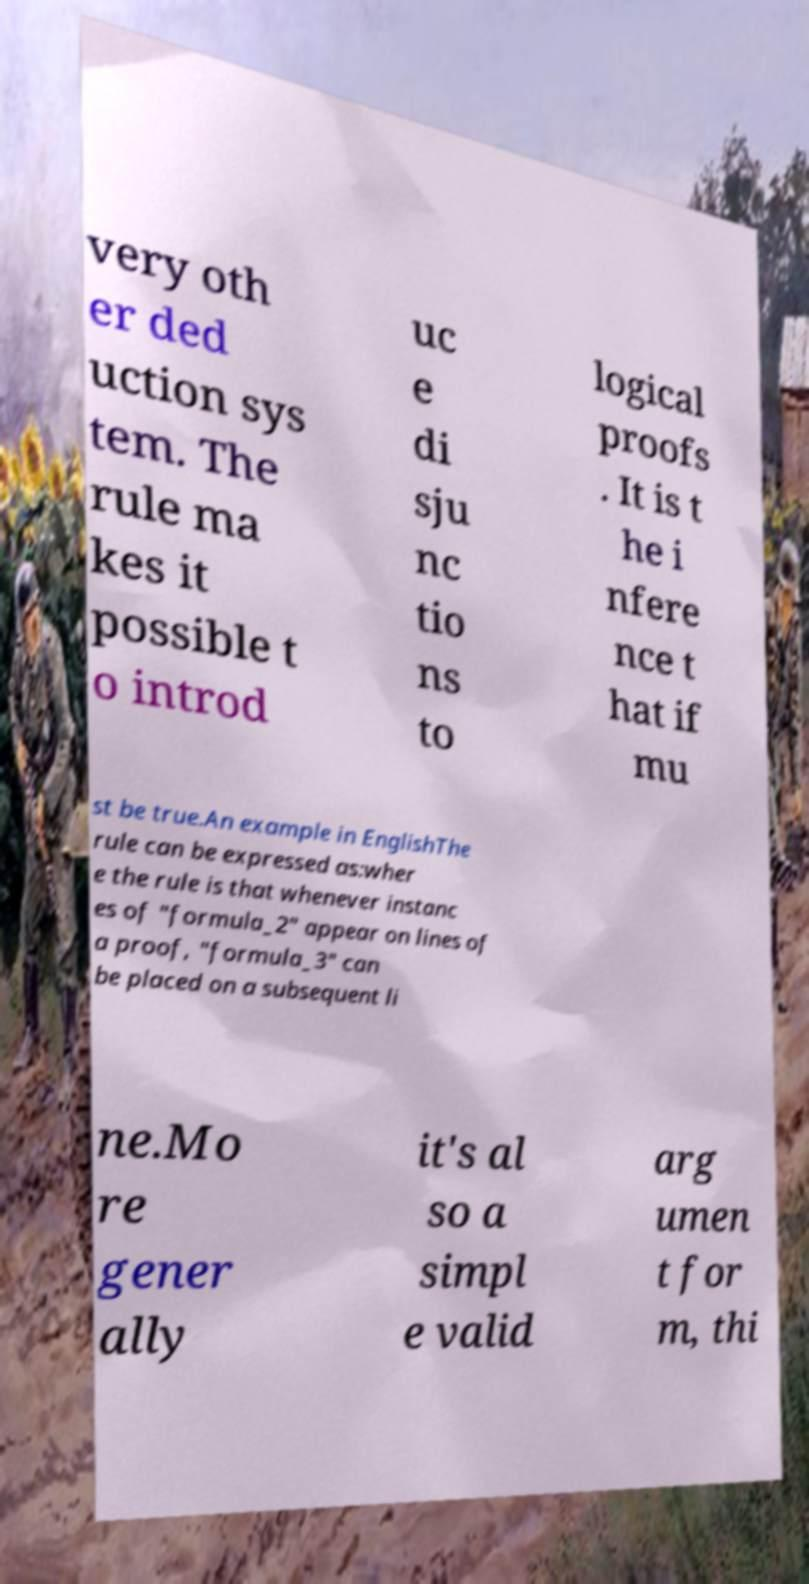Please read and relay the text visible in this image. What does it say? very oth er ded uction sys tem. The rule ma kes it possible t o introd uc e di sju nc tio ns to logical proofs . It is t he i nfere nce t hat if mu st be true.An example in EnglishThe rule can be expressed as:wher e the rule is that whenever instanc es of "formula_2" appear on lines of a proof, "formula_3" can be placed on a subsequent li ne.Mo re gener ally it's al so a simpl e valid arg umen t for m, thi 